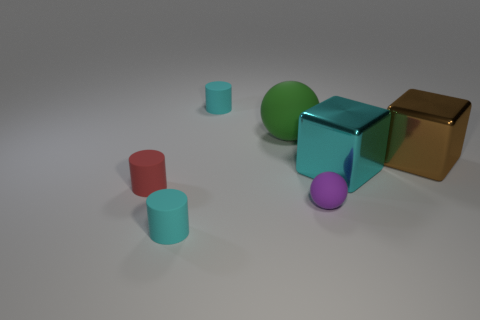Does the rubber sphere in front of the red matte cylinder have the same size as the matte cylinder that is in front of the small red rubber cylinder?
Offer a terse response. Yes. Is the number of tiny cyan rubber objects that are to the right of the purple rubber object less than the number of big shiny blocks that are to the right of the cyan metal cube?
Provide a short and direct response. Yes. There is a sphere behind the purple thing; what is its color?
Ensure brevity in your answer.  Green. There is a tiny cyan matte cylinder that is in front of the small object behind the green sphere; what number of cylinders are behind it?
Provide a succinct answer. 2. How big is the red cylinder?
Keep it short and to the point. Small. What is the material of the cyan block that is the same size as the green matte thing?
Give a very brief answer. Metal. How many rubber balls are behind the cyan metal cube?
Offer a terse response. 1. Does the cyan cylinder that is in front of the tiny purple object have the same material as the cyan object to the right of the purple sphere?
Offer a terse response. No. What is the shape of the tiny cyan matte thing that is on the right side of the small cyan cylinder that is in front of the cyan rubber thing that is behind the big rubber ball?
Your answer should be compact. Cylinder. The big cyan object is what shape?
Provide a short and direct response. Cube. 